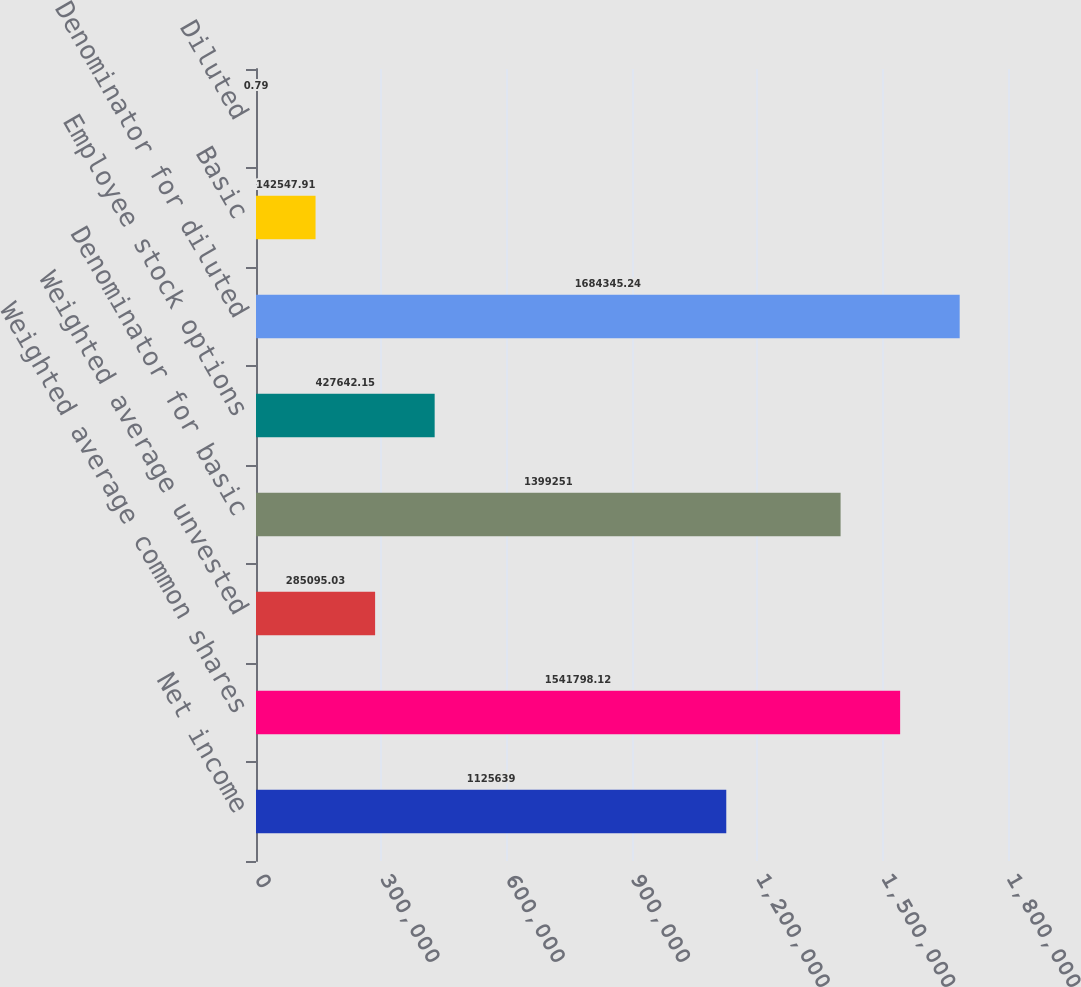Convert chart. <chart><loc_0><loc_0><loc_500><loc_500><bar_chart><fcel>Net income<fcel>Weighted average common shares<fcel>Weighted average unvested<fcel>Denominator for basic<fcel>Employee stock options<fcel>Denominator for diluted<fcel>Basic<fcel>Diluted<nl><fcel>1.12564e+06<fcel>1.5418e+06<fcel>285095<fcel>1.39925e+06<fcel>427642<fcel>1.68435e+06<fcel>142548<fcel>0.79<nl></chart> 